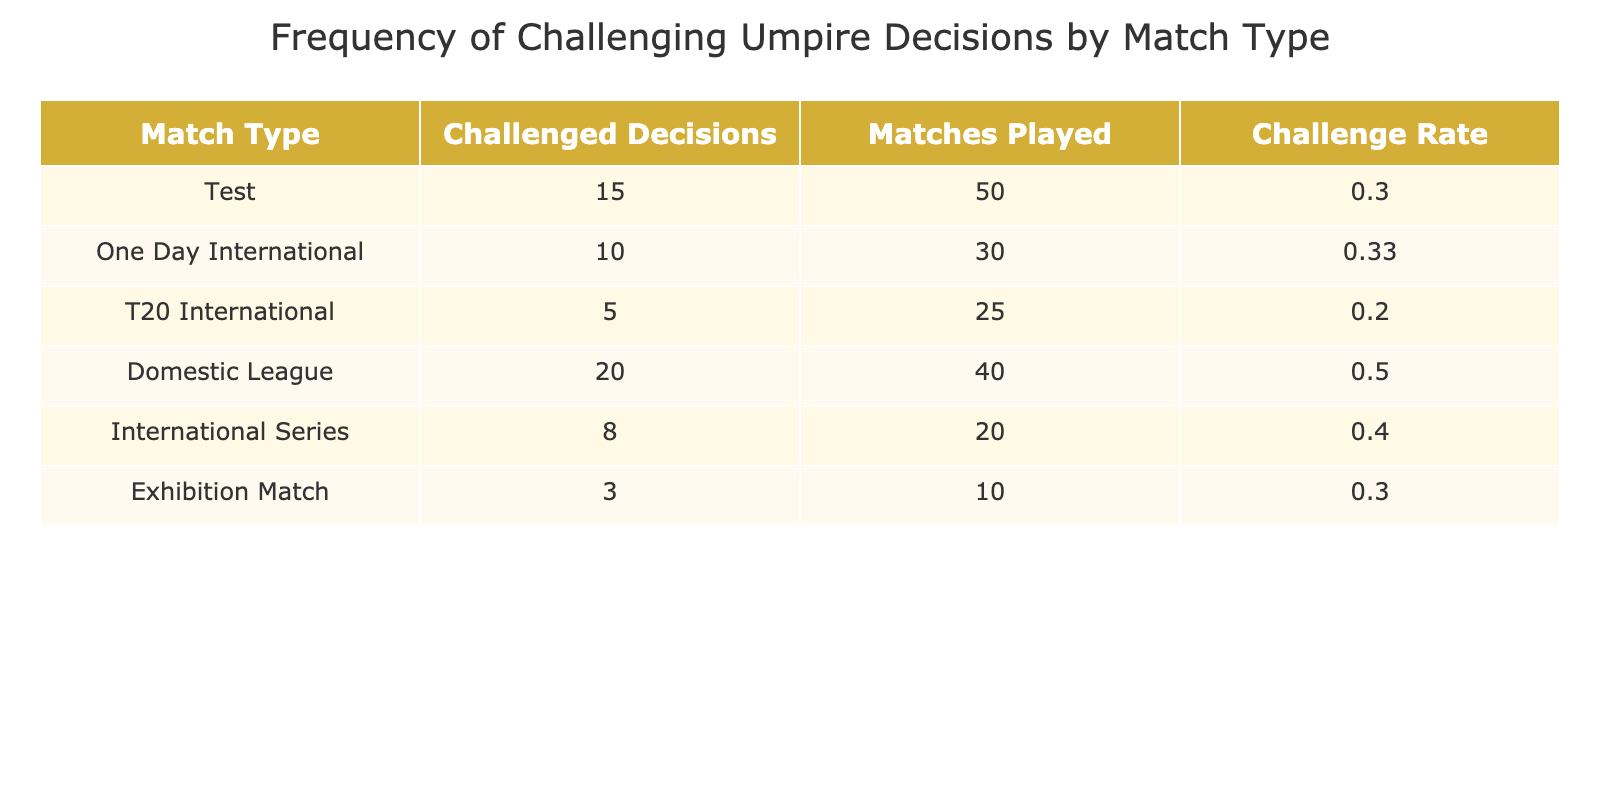What is the match type with the highest number of challenged decisions? By looking at the "Challenged Decisions" column, we see the Domestic League has the highest count at 20. Other match types have lower values, confirming Domestic League as the one with the most challenges.
Answer: Domestic League How many matches were played in T20 Internationals? In the "Matches Played" column, the T20 International row shows that 25 matches were played, which gives us the answer directly.
Answer: 25 What is the challenge rate for One Day Internationals? For One Day Internationals, we check the "Challenge Rate" column where it lists 0.33. This is derived from dividing the number of challenged decisions (10) by the matches played (30) and rounding it.
Answer: 0.33 Is it true that the Test matches had more challenged decisions than Domestic Leagues? By comparing the values in the "Challenged Decisions" column, we see that Test matches had 15 challenges while Domestic League had 20. Therefore, the statement is false.
Answer: No What is the total number of matches played across all types? To find this, we add all values in the "Matches Played" column: 50 + 30 + 25 + 40 + 20 + 10 = 175, giving the total count.
Answer: 175 What is the average challenge rate across all match types? First, we need to calculate the challenge rates for each match type: Test (0.30), ODI (0.33), T20 (0.20), Domestic League (0.50), International Series (0.40), and Exhibition Match (0.30). Next, we sum these rates: 0.30 + 0.33 + 0.20 + 0.50 + 0.40 + 0.30 = 2.03 and divide by the number of types (6). This gives us an average challenge rate of about 0.34.
Answer: 0.34 Which match type has the lowest challenge rate? Looking in the "Challenge Rate" column, we can see that T20 International has a rate of 0.20, which is the lowest compared to other types, confirming it has the least challenges per match.
Answer: T20 International Does the average challenge rate for Domestic League exceed 0.40? The challenge rate for Domestic League is 0.50, which is higher than 0.40, verifying the statement as true.
Answer: Yes 